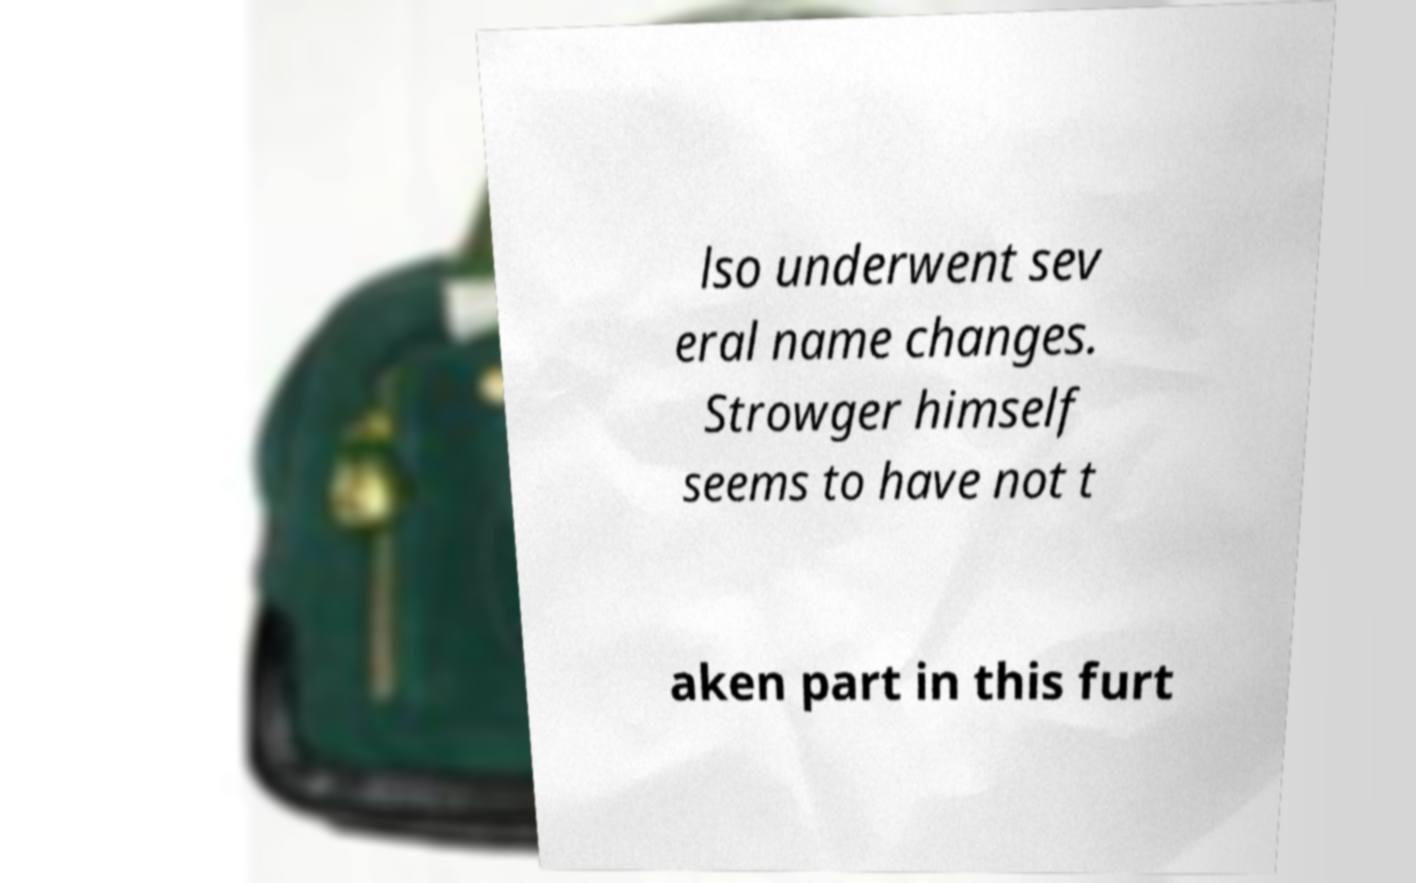Could you extract and type out the text from this image? lso underwent sev eral name changes. Strowger himself seems to have not t aken part in this furt 